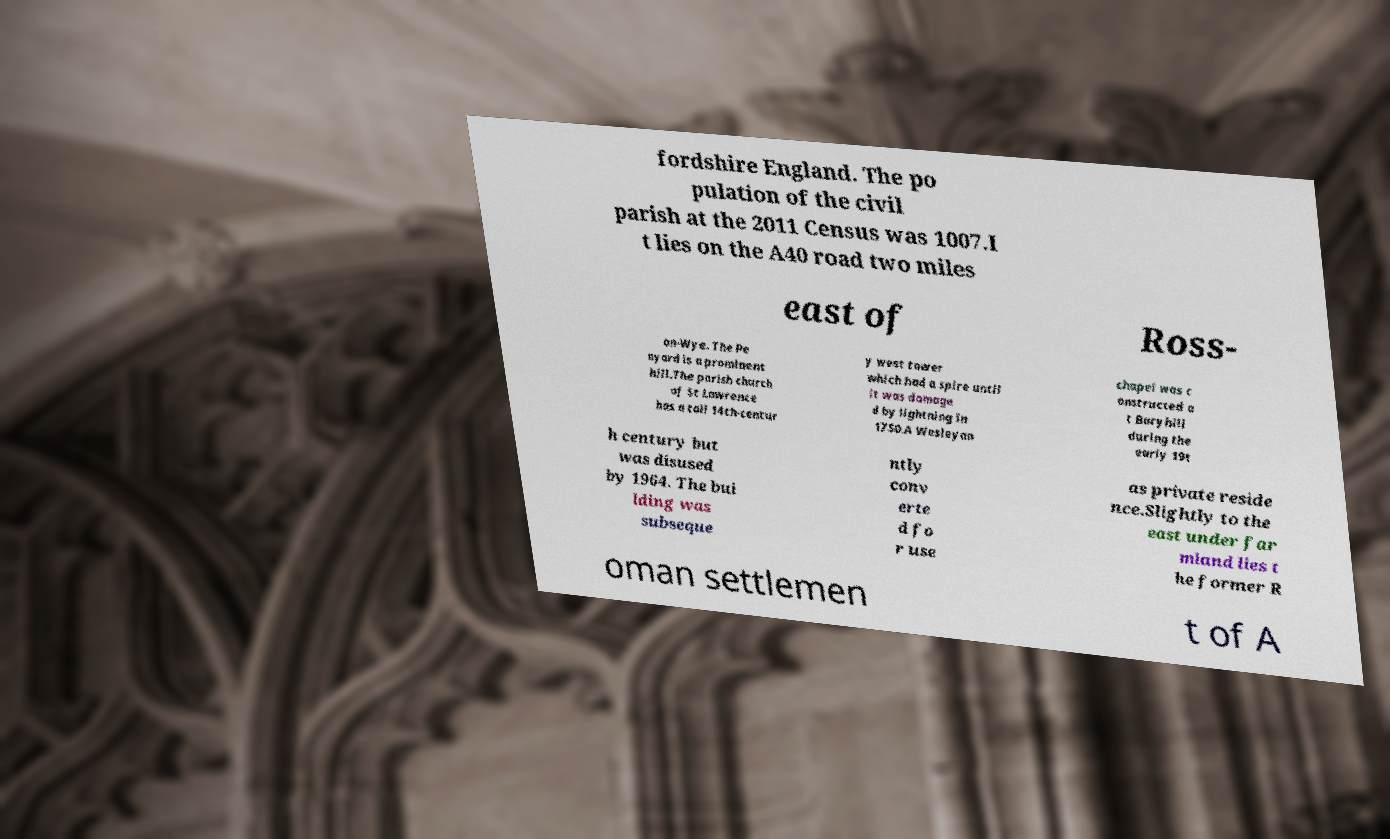There's text embedded in this image that I need extracted. Can you transcribe it verbatim? fordshire England. The po pulation of the civil parish at the 2011 Census was 1007.I t lies on the A40 road two miles east of Ross- on-Wye. The Pe nyard is a prominent hill.The parish church of St Lawrence has a tall 14th-centur y west tower which had a spire until it was damage d by lightning in 1750.A Wesleyan chapel was c onstructed a t Buryhill during the early 19t h century but was disused by 1964. The bui lding was subseque ntly conv erte d fo r use as private reside nce.Slightly to the east under far mland lies t he former R oman settlemen t of A 